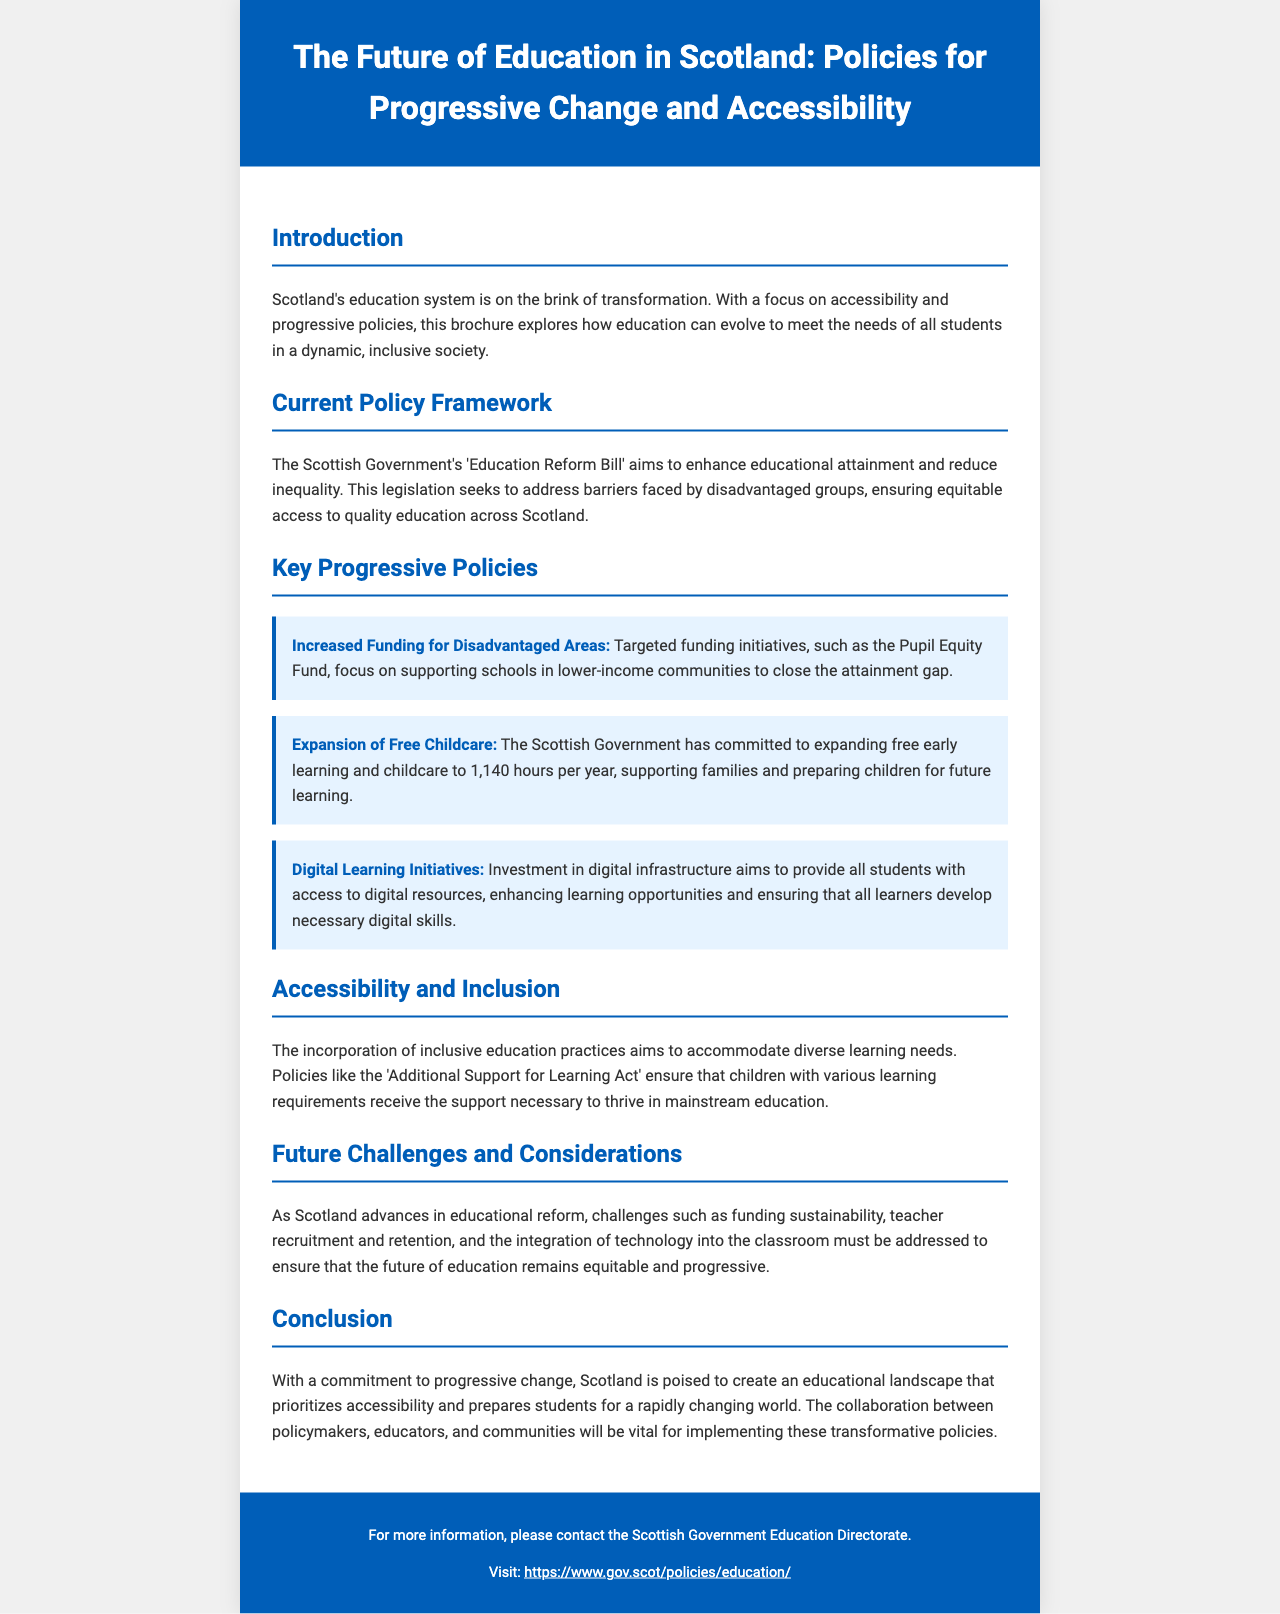What is the title of the brochure? The title of the brochure is stated at the top of the document, focusing on education in Scotland.
Answer: The Future of Education in Scotland: Policies for Progressive Change and Accessibility What is the main goal of the 'Education Reform Bill'? This bill aims to enhance educational attainment and reduce inequality across Scotland.
Answer: Enhance educational attainment and reduce inequality How many hours of free childcare has the Scottish Government committed to expand? The document specifies the amount of free childcare being expanded within a year.
Answer: 1,140 hours What does the Pupil Equity Fund target? The Pupil Equity Fund focuses on supporting specific communities within Scotland.
Answer: Disadvantaged Areas Which act ensures support for children with learning requirements? This act is mentioned in relation to inclusive education practices within the document.
Answer: Additional Support for Learning Act What type of infrastructure is being invested in according to the document? The investment mentioned is essential for providing students with necessary resources.
Answer: Digital infrastructure What are the potential challenges for education reform in Scotland? The document outlines specific challenges that need to be addressed for effective reform.
Answer: Funding sustainability, teacher recruitment and retention, technology integration What is the key focus of the accessible education initiatives mentioned? The document highlights a specific educational practice aimed at diverse learning needs.
Answer: Inclusive education practices 